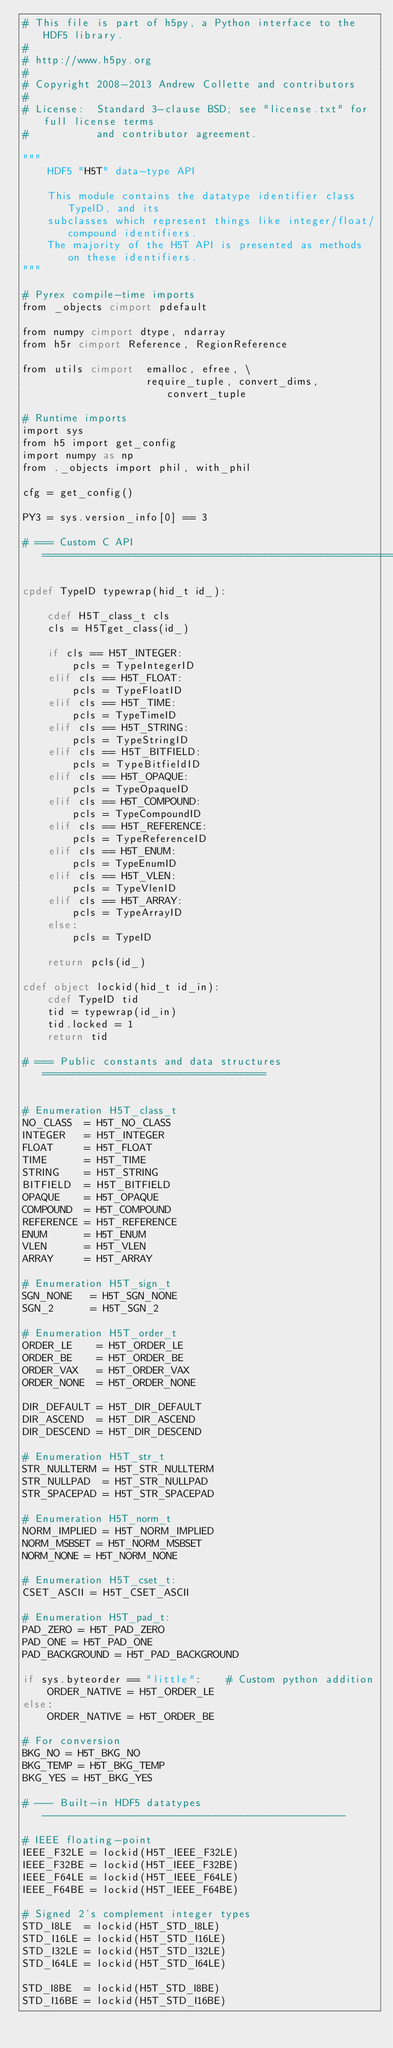Convert code to text. <code><loc_0><loc_0><loc_500><loc_500><_Cython_># This file is part of h5py, a Python interface to the HDF5 library.
#
# http://www.h5py.org
#
# Copyright 2008-2013 Andrew Collette and contributors
#
# License:  Standard 3-clause BSD; see "license.txt" for full license terms
#           and contributor agreement.

"""
    HDF5 "H5T" data-type API

    This module contains the datatype identifier class TypeID, and its
    subclasses which represent things like integer/float/compound identifiers.
    The majority of the H5T API is presented as methods on these identifiers.
"""

# Pyrex compile-time imports
from _objects cimport pdefault

from numpy cimport dtype, ndarray
from h5r cimport Reference, RegionReference

from utils cimport  emalloc, efree, \
                    require_tuple, convert_dims, convert_tuple

# Runtime imports
import sys
from h5 import get_config
import numpy as np
from ._objects import phil, with_phil

cfg = get_config()

PY3 = sys.version_info[0] == 3

# === Custom C API ============================================================

cpdef TypeID typewrap(hid_t id_):

    cdef H5T_class_t cls
    cls = H5Tget_class(id_)

    if cls == H5T_INTEGER:
        pcls = TypeIntegerID
    elif cls == H5T_FLOAT:
        pcls = TypeFloatID
    elif cls == H5T_TIME:
        pcls = TypeTimeID
    elif cls == H5T_STRING:
        pcls = TypeStringID
    elif cls == H5T_BITFIELD:
        pcls = TypeBitfieldID
    elif cls == H5T_OPAQUE:
        pcls = TypeOpaqueID
    elif cls == H5T_COMPOUND:
        pcls = TypeCompoundID
    elif cls == H5T_REFERENCE:
        pcls = TypeReferenceID
    elif cls == H5T_ENUM:
        pcls = TypeEnumID
    elif cls == H5T_VLEN:
        pcls = TypeVlenID
    elif cls == H5T_ARRAY:
        pcls = TypeArrayID
    else:
        pcls = TypeID

    return pcls(id_)

cdef object lockid(hid_t id_in):
    cdef TypeID tid
    tid = typewrap(id_in)
    tid.locked = 1
    return tid

# === Public constants and data structures ====================================


# Enumeration H5T_class_t
NO_CLASS  = H5T_NO_CLASS
INTEGER   = H5T_INTEGER
FLOAT     = H5T_FLOAT
TIME      = H5T_TIME
STRING    = H5T_STRING
BITFIELD  = H5T_BITFIELD
OPAQUE    = H5T_OPAQUE
COMPOUND  = H5T_COMPOUND
REFERENCE = H5T_REFERENCE
ENUM      = H5T_ENUM
VLEN      = H5T_VLEN
ARRAY     = H5T_ARRAY

# Enumeration H5T_sign_t
SGN_NONE   = H5T_SGN_NONE
SGN_2      = H5T_SGN_2

# Enumeration H5T_order_t
ORDER_LE    = H5T_ORDER_LE
ORDER_BE    = H5T_ORDER_BE
ORDER_VAX   = H5T_ORDER_VAX
ORDER_NONE  = H5T_ORDER_NONE

DIR_DEFAULT = H5T_DIR_DEFAULT
DIR_ASCEND  = H5T_DIR_ASCEND
DIR_DESCEND = H5T_DIR_DESCEND

# Enumeration H5T_str_t
STR_NULLTERM = H5T_STR_NULLTERM
STR_NULLPAD  = H5T_STR_NULLPAD
STR_SPACEPAD = H5T_STR_SPACEPAD

# Enumeration H5T_norm_t
NORM_IMPLIED = H5T_NORM_IMPLIED
NORM_MSBSET = H5T_NORM_MSBSET
NORM_NONE = H5T_NORM_NONE

# Enumeration H5T_cset_t:
CSET_ASCII = H5T_CSET_ASCII

# Enumeration H5T_pad_t:
PAD_ZERO = H5T_PAD_ZERO
PAD_ONE = H5T_PAD_ONE
PAD_BACKGROUND = H5T_PAD_BACKGROUND

if sys.byteorder == "little":    # Custom python addition
    ORDER_NATIVE = H5T_ORDER_LE
else:
    ORDER_NATIVE = H5T_ORDER_BE

# For conversion
BKG_NO = H5T_BKG_NO
BKG_TEMP = H5T_BKG_TEMP
BKG_YES = H5T_BKG_YES

# --- Built-in HDF5 datatypes -------------------------------------------------

# IEEE floating-point
IEEE_F32LE = lockid(H5T_IEEE_F32LE)
IEEE_F32BE = lockid(H5T_IEEE_F32BE)
IEEE_F64LE = lockid(H5T_IEEE_F64LE)
IEEE_F64BE = lockid(H5T_IEEE_F64BE)

# Signed 2's complement integer types
STD_I8LE  = lockid(H5T_STD_I8LE)
STD_I16LE = lockid(H5T_STD_I16LE)
STD_I32LE = lockid(H5T_STD_I32LE)
STD_I64LE = lockid(H5T_STD_I64LE)

STD_I8BE  = lockid(H5T_STD_I8BE)
STD_I16BE = lockid(H5T_STD_I16BE)</code> 